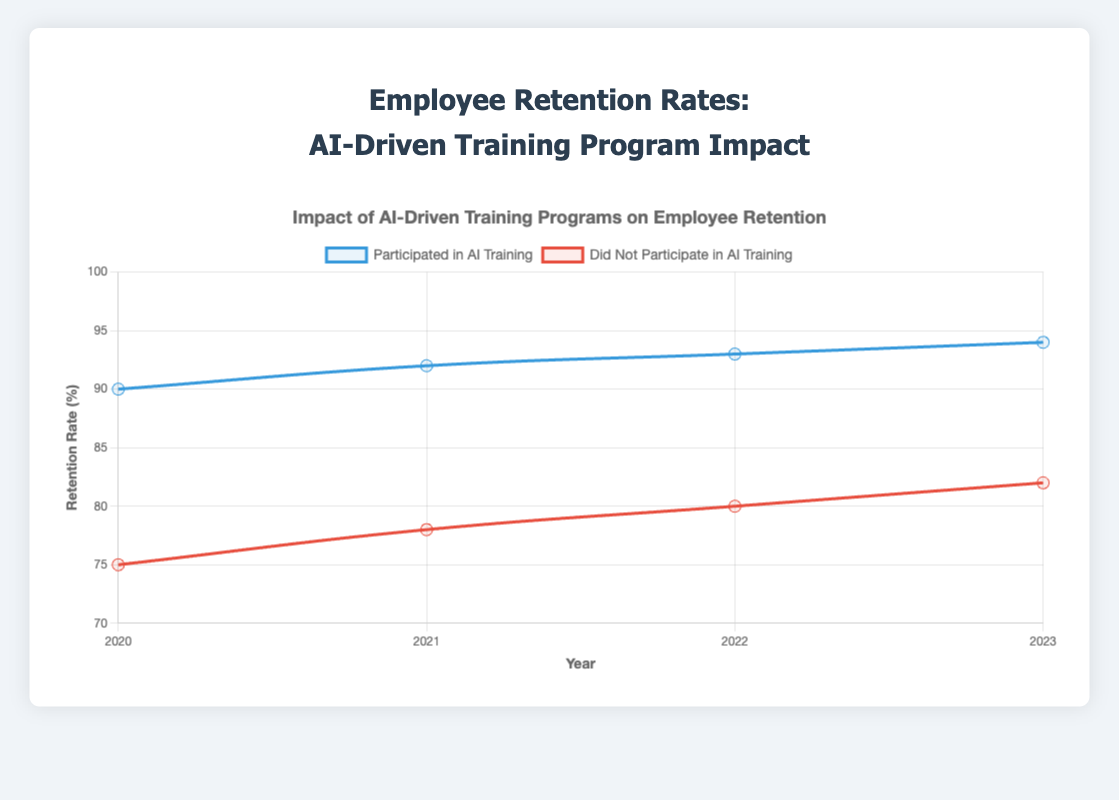What is the retention rate for employees who participated in AI training in 2023? The graph shows the retention rate for each year and participation category. For employees who participated in AI training in 2023, the retention rate is marked near the highest point on the blue line.
Answer: 94% How does the retention rate in 2021 for employees who did not participate in AI training compare to the retention rate in 2022 for the same group? To compare, look at the red line's points for the years 2021 and 2022. The retention rate for employees who did not participate in AI training is 78% in 2021 and 80% in 2022.
Answer: 78% (2021) is less than 80% (2022) What is the trend of retention rates from 2020 to 2023 for employees who participated in AI training? Observing the blue line from 2020 to 2023, the retention rate starts at 90% in 2020 and increases annually, reaching 94% by 2023. This shows a consistent upward trend.
Answer: Increasing What is the difference between the retention rates of participants and non-participants in AI training in the year 2020? In 2020, the retention rate for participants in AI training is 90%, while for non-participants it is 75%. The difference is 90% - 75% = 15%.
Answer: 15% Calculate the average retention rate for employees who did not participate in AI training from 2020 to 2023. The retention rates are: 2020: 75%, 2021: 78%, 2022: 80%, 2023: 82%. Add these and divide by 4. (75 + 78 + 80 + 82) / 4 = 315 / 4 = 78.75%.
Answer: 78.75% Which participation group had the highest retention rate at any point from 2020 to 2023, and what was the rate? Looking at both lines, the highest point is marked on the blue line for participants in AI training, reaching 94% in 2023.
Answer: Participants in AI training, 94% Compare the visual attributes of the lines representing participants and non-participants in AI training. What are the significant differences? The blue line represents participants with higher retention rates and an upward trend, while the red line represents non-participants with lower retention rates and a slight upward trend. The blue line is consistently above the red line, showing better retention rates for participants.
Answer: Blue line is higher, Red line is lower What is the retention rate difference between participants and non-participants in AI training in 2022? In 2022, the retention rate for participants is 93% and for non-participants is 80%. The difference is 93% - 80% = 13%.
Answer: 13% 